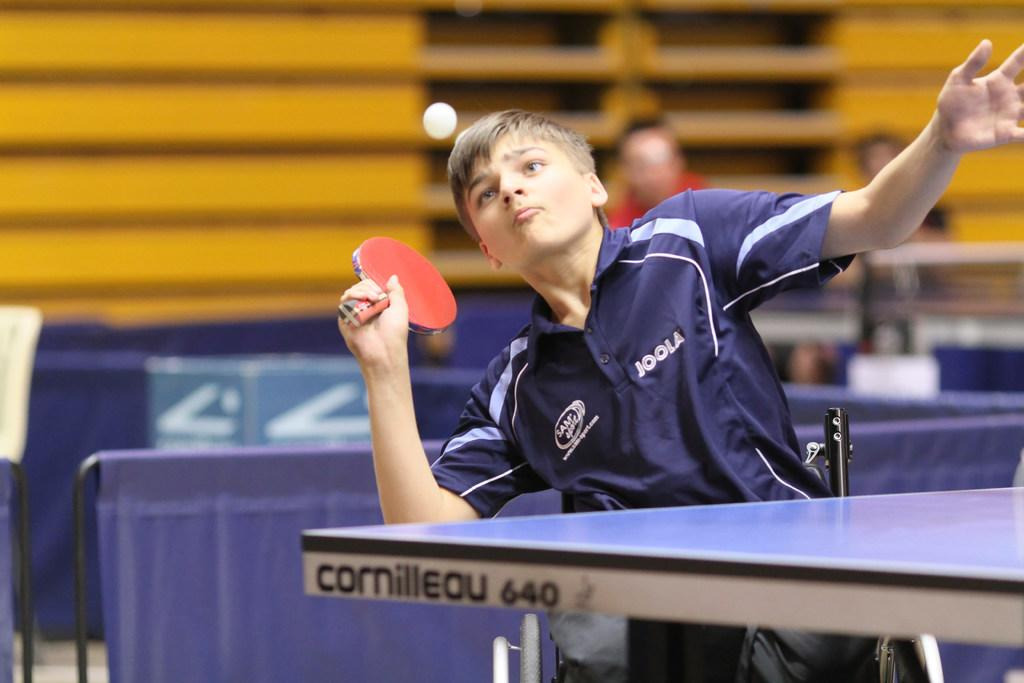Who is the main subject in the image? There is a boy in the image. What is the boy holding in the image? The boy is holding a table tennis bat. What action is the boy performing with the table tennis bat? The boy is hitting a ball. What type of table is present in the image? There is a table tennis table in the image. How many girls are playing with the chicken in the image? There are no girls or chickens present in the image; it features a boy playing table tennis. 